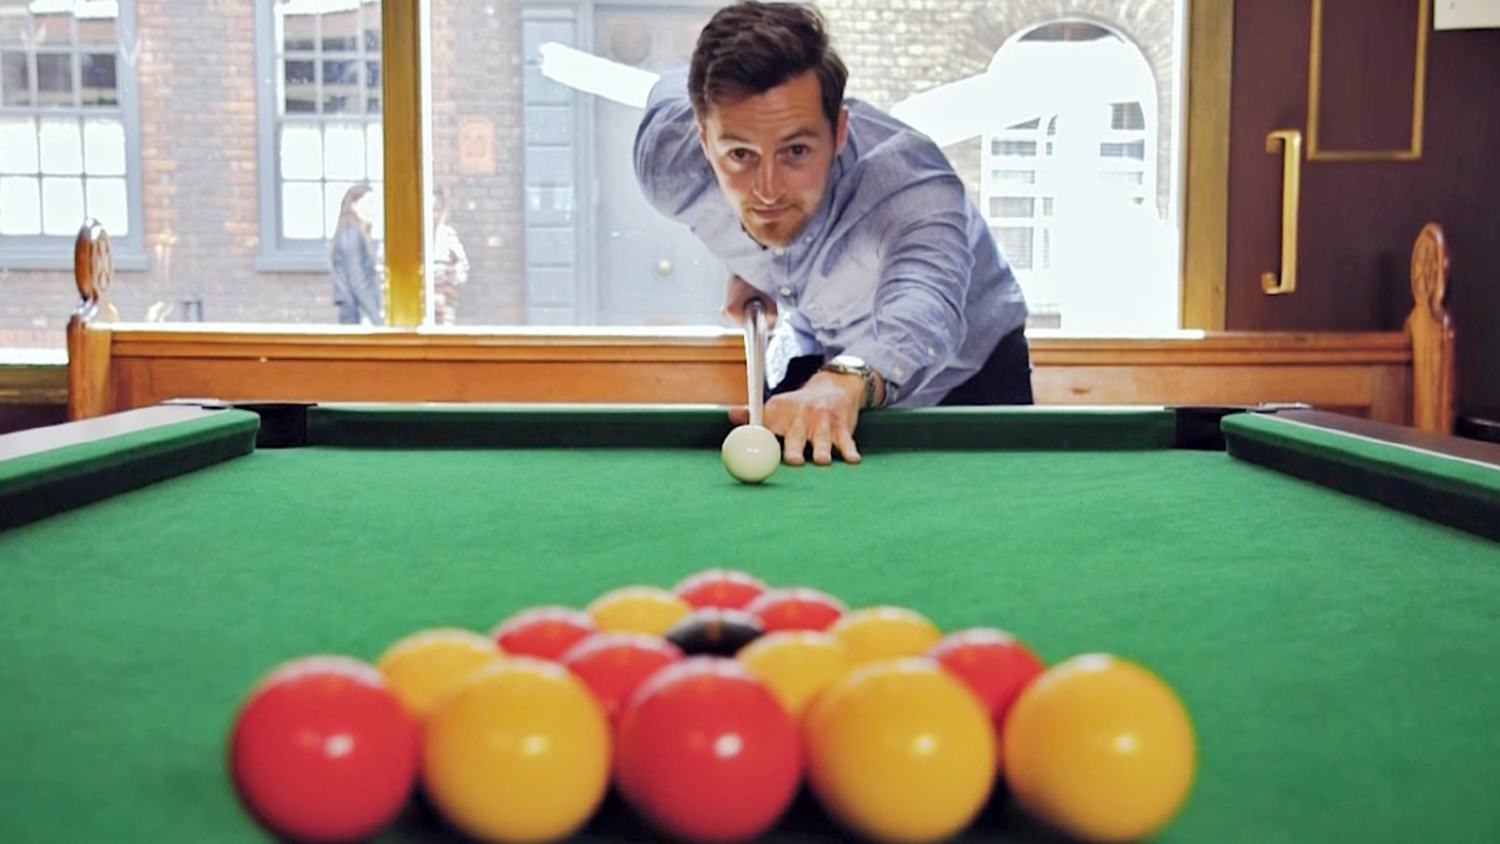Based on the arrangement of the pool balls and the man's positioning, what can be inferred about his level of experience or expertise in playing pool? Based on the arrangement of the pool balls and the man's positioning, it can be inferred that he likely has some experience and expertise in playing pool. His posture is confident, with a focused expression, which demonstrates familiarity with the game. He's adopting a proper stance with a stable bridge hand and a cue that is straight and aligned towards the cue ball, indicating an understanding of the mechanics necessary for a precise shot. However, to more accurately assess his level of skill, one would need to observe the execution of his shots, assessing his precision and consistency over multiple plays. 